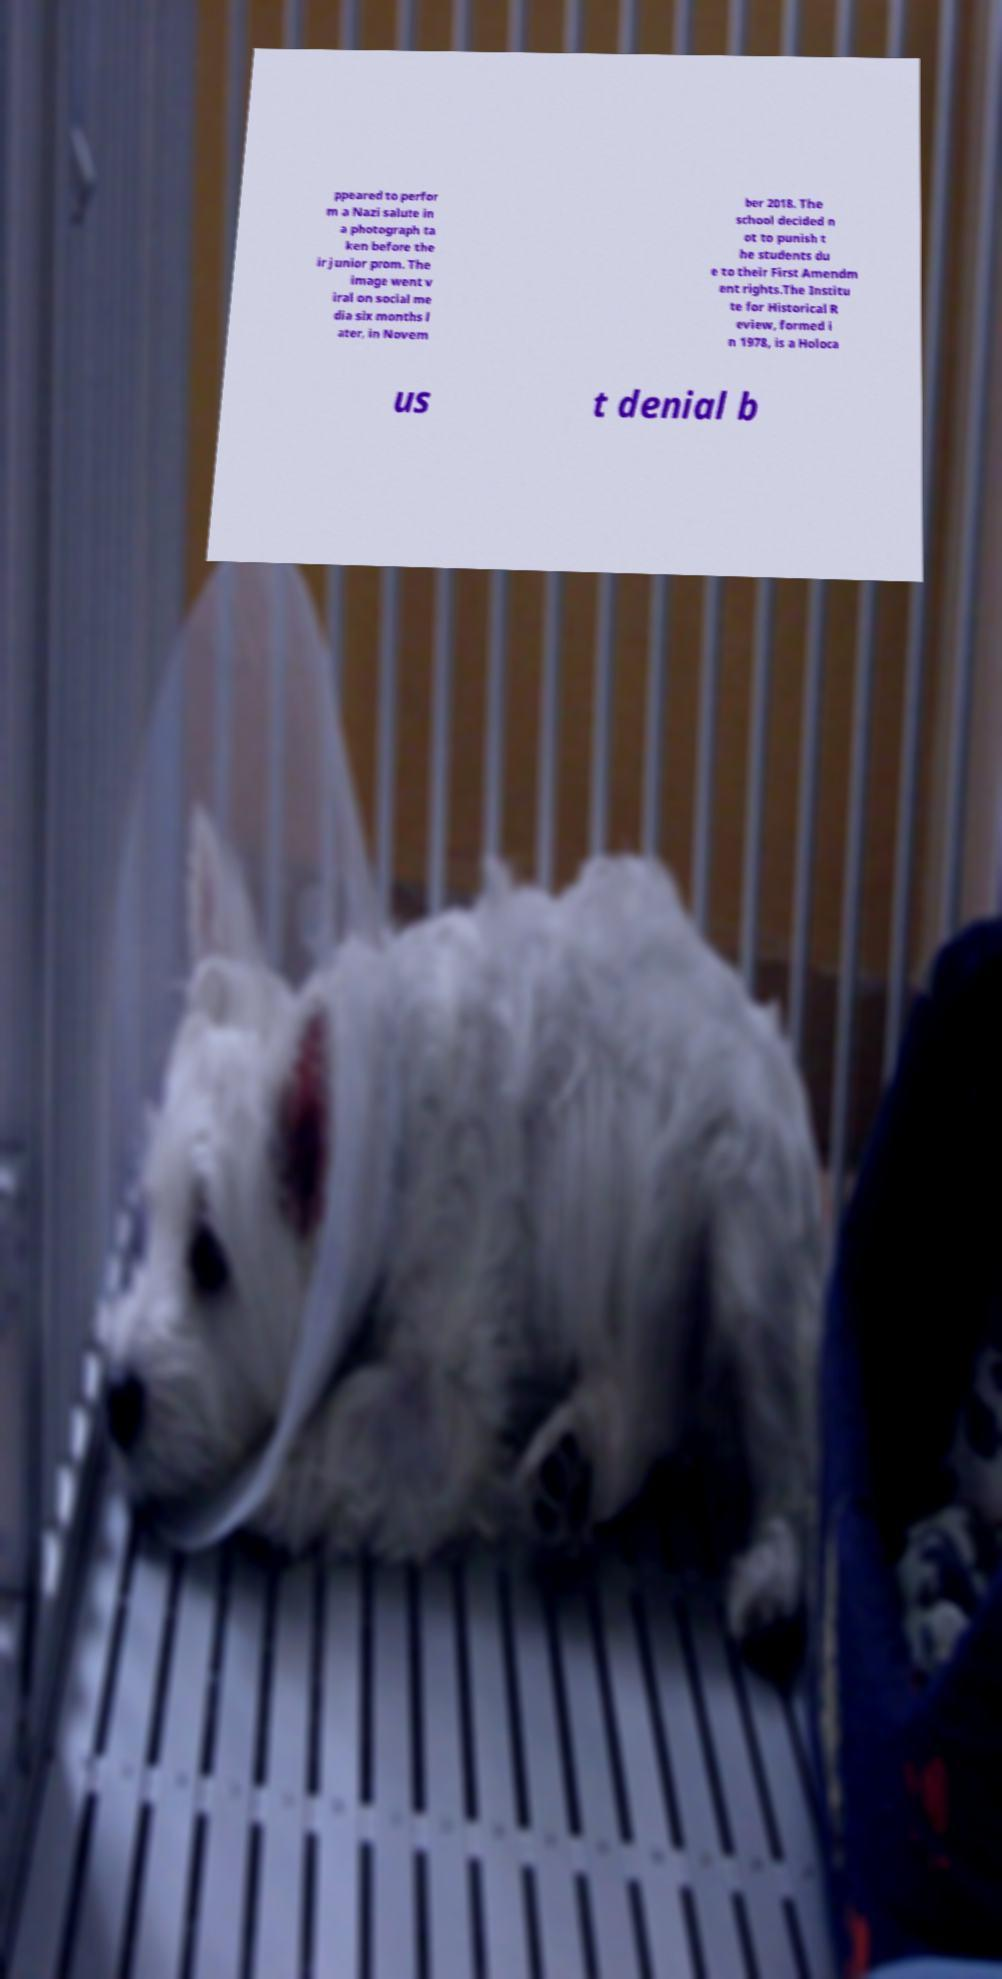Could you extract and type out the text from this image? ppeared to perfor m a Nazi salute in a photograph ta ken before the ir junior prom. The image went v iral on social me dia six months l ater, in Novem ber 2018. The school decided n ot to punish t he students du e to their First Amendm ent rights.The Institu te for Historical R eview, formed i n 1978, is a Holoca us t denial b 